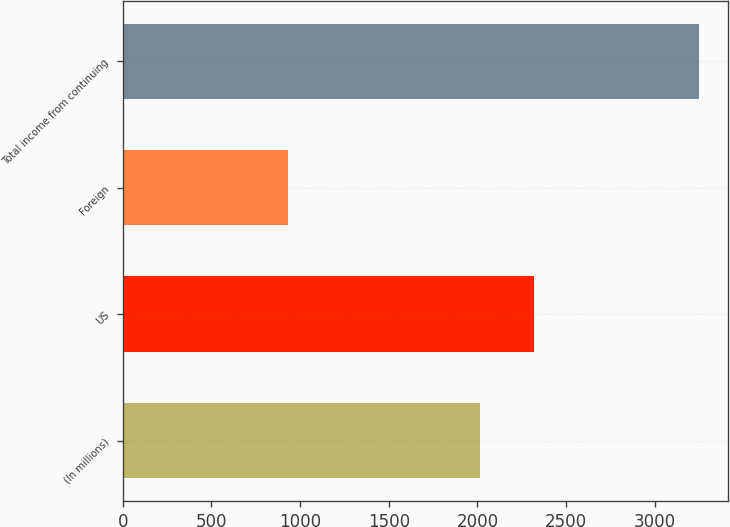Convert chart to OTSL. <chart><loc_0><loc_0><loc_500><loc_500><bar_chart><fcel>(In millions)<fcel>US<fcel>Foreign<fcel>Total income from continuing<nl><fcel>2016<fcel>2319<fcel>931<fcel>3250<nl></chart> 